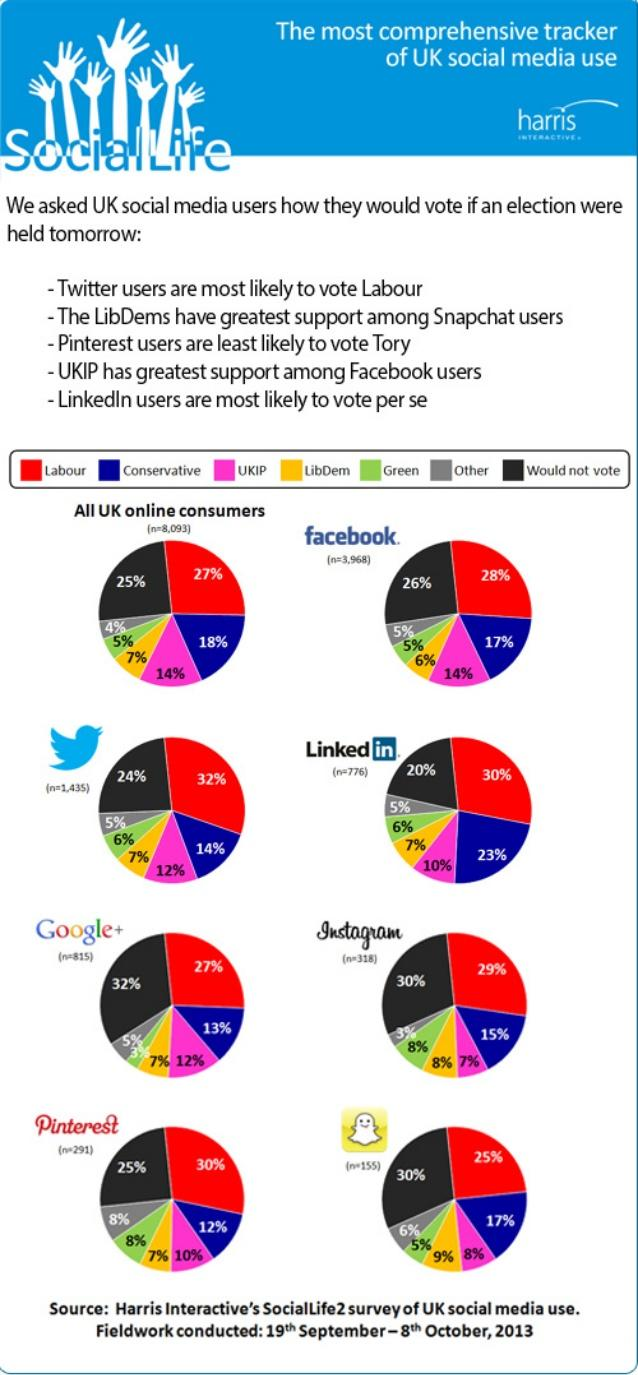Indicate a few pertinent items in this graphic. A majority of Instagram users, approximately 70%, would like to vote. The percentage of users who do not want to vote is higher on Google. This infographic contains eight pie charts. Among all UK online consumers, the percentage of conservative and UKIP supporters is 4%. According to a survey, 47% of LinkedIn users do not support conservative or labor beliefs. 